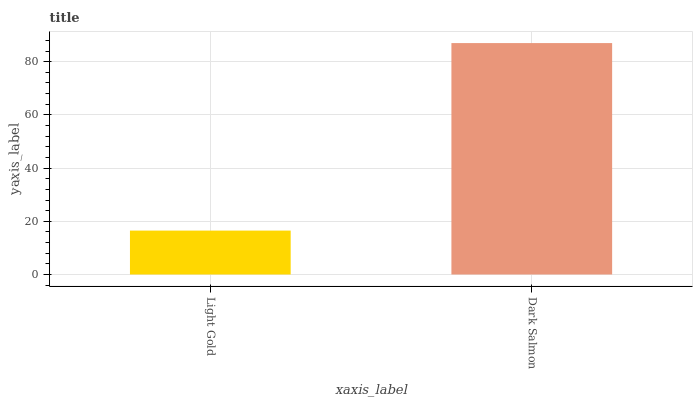Is Light Gold the minimum?
Answer yes or no. Yes. Is Dark Salmon the maximum?
Answer yes or no. Yes. Is Dark Salmon the minimum?
Answer yes or no. No. Is Dark Salmon greater than Light Gold?
Answer yes or no. Yes. Is Light Gold less than Dark Salmon?
Answer yes or no. Yes. Is Light Gold greater than Dark Salmon?
Answer yes or no. No. Is Dark Salmon less than Light Gold?
Answer yes or no. No. Is Dark Salmon the high median?
Answer yes or no. Yes. Is Light Gold the low median?
Answer yes or no. Yes. Is Light Gold the high median?
Answer yes or no. No. Is Dark Salmon the low median?
Answer yes or no. No. 